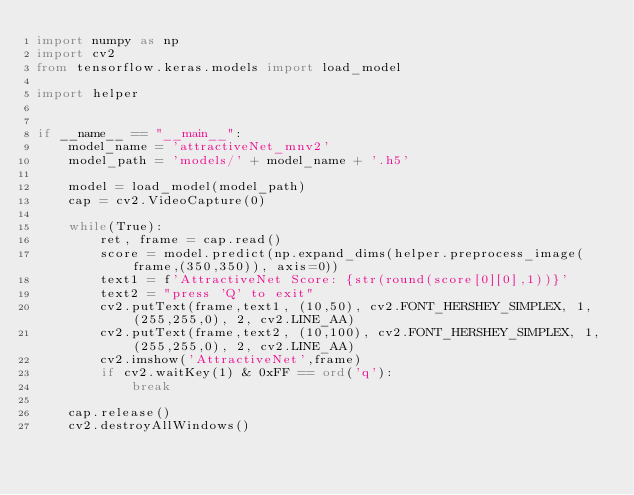Convert code to text. <code><loc_0><loc_0><loc_500><loc_500><_Python_>import numpy as np
import cv2
from tensorflow.keras.models import load_model

import helper


if __name__ == "__main__":
    model_name = 'attractiveNet_mnv2'
    model_path = 'models/' + model_name + '.h5'

    model = load_model(model_path)
    cap = cv2.VideoCapture(0)

    while(True):
        ret, frame = cap.read()
        score = model.predict(np.expand_dims(helper.preprocess_image(frame,(350,350)), axis=0))
        text1 = f'AttractiveNet Score: {str(round(score[0][0],1))}'
        text2 = "press 'Q' to exit"
        cv2.putText(frame,text1, (10,50), cv2.FONT_HERSHEY_SIMPLEX, 1, (255,255,0), 2, cv2.LINE_AA)
        cv2.putText(frame,text2, (10,100), cv2.FONT_HERSHEY_SIMPLEX, 1, (255,255,0), 2, cv2.LINE_AA)
        cv2.imshow('AttractiveNet',frame)
        if cv2.waitKey(1) & 0xFF == ord('q'):
            break

    cap.release()
    cv2.destroyAllWindows()</code> 